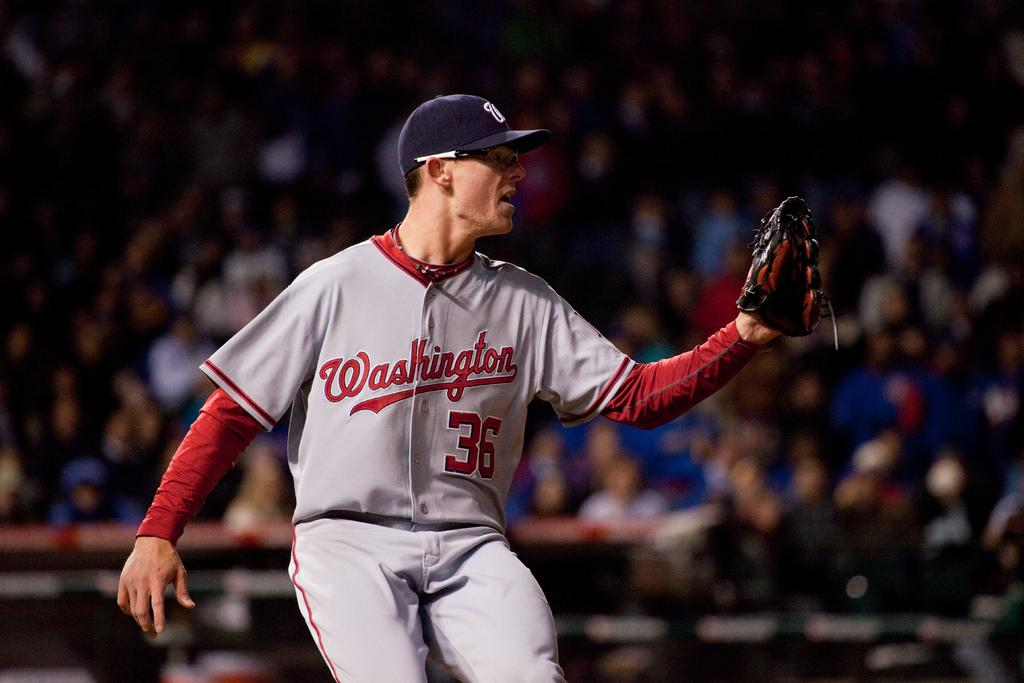<image>
Write a terse but informative summary of the picture. A baseball player wears a Washington uniform with the number 36 on it. 